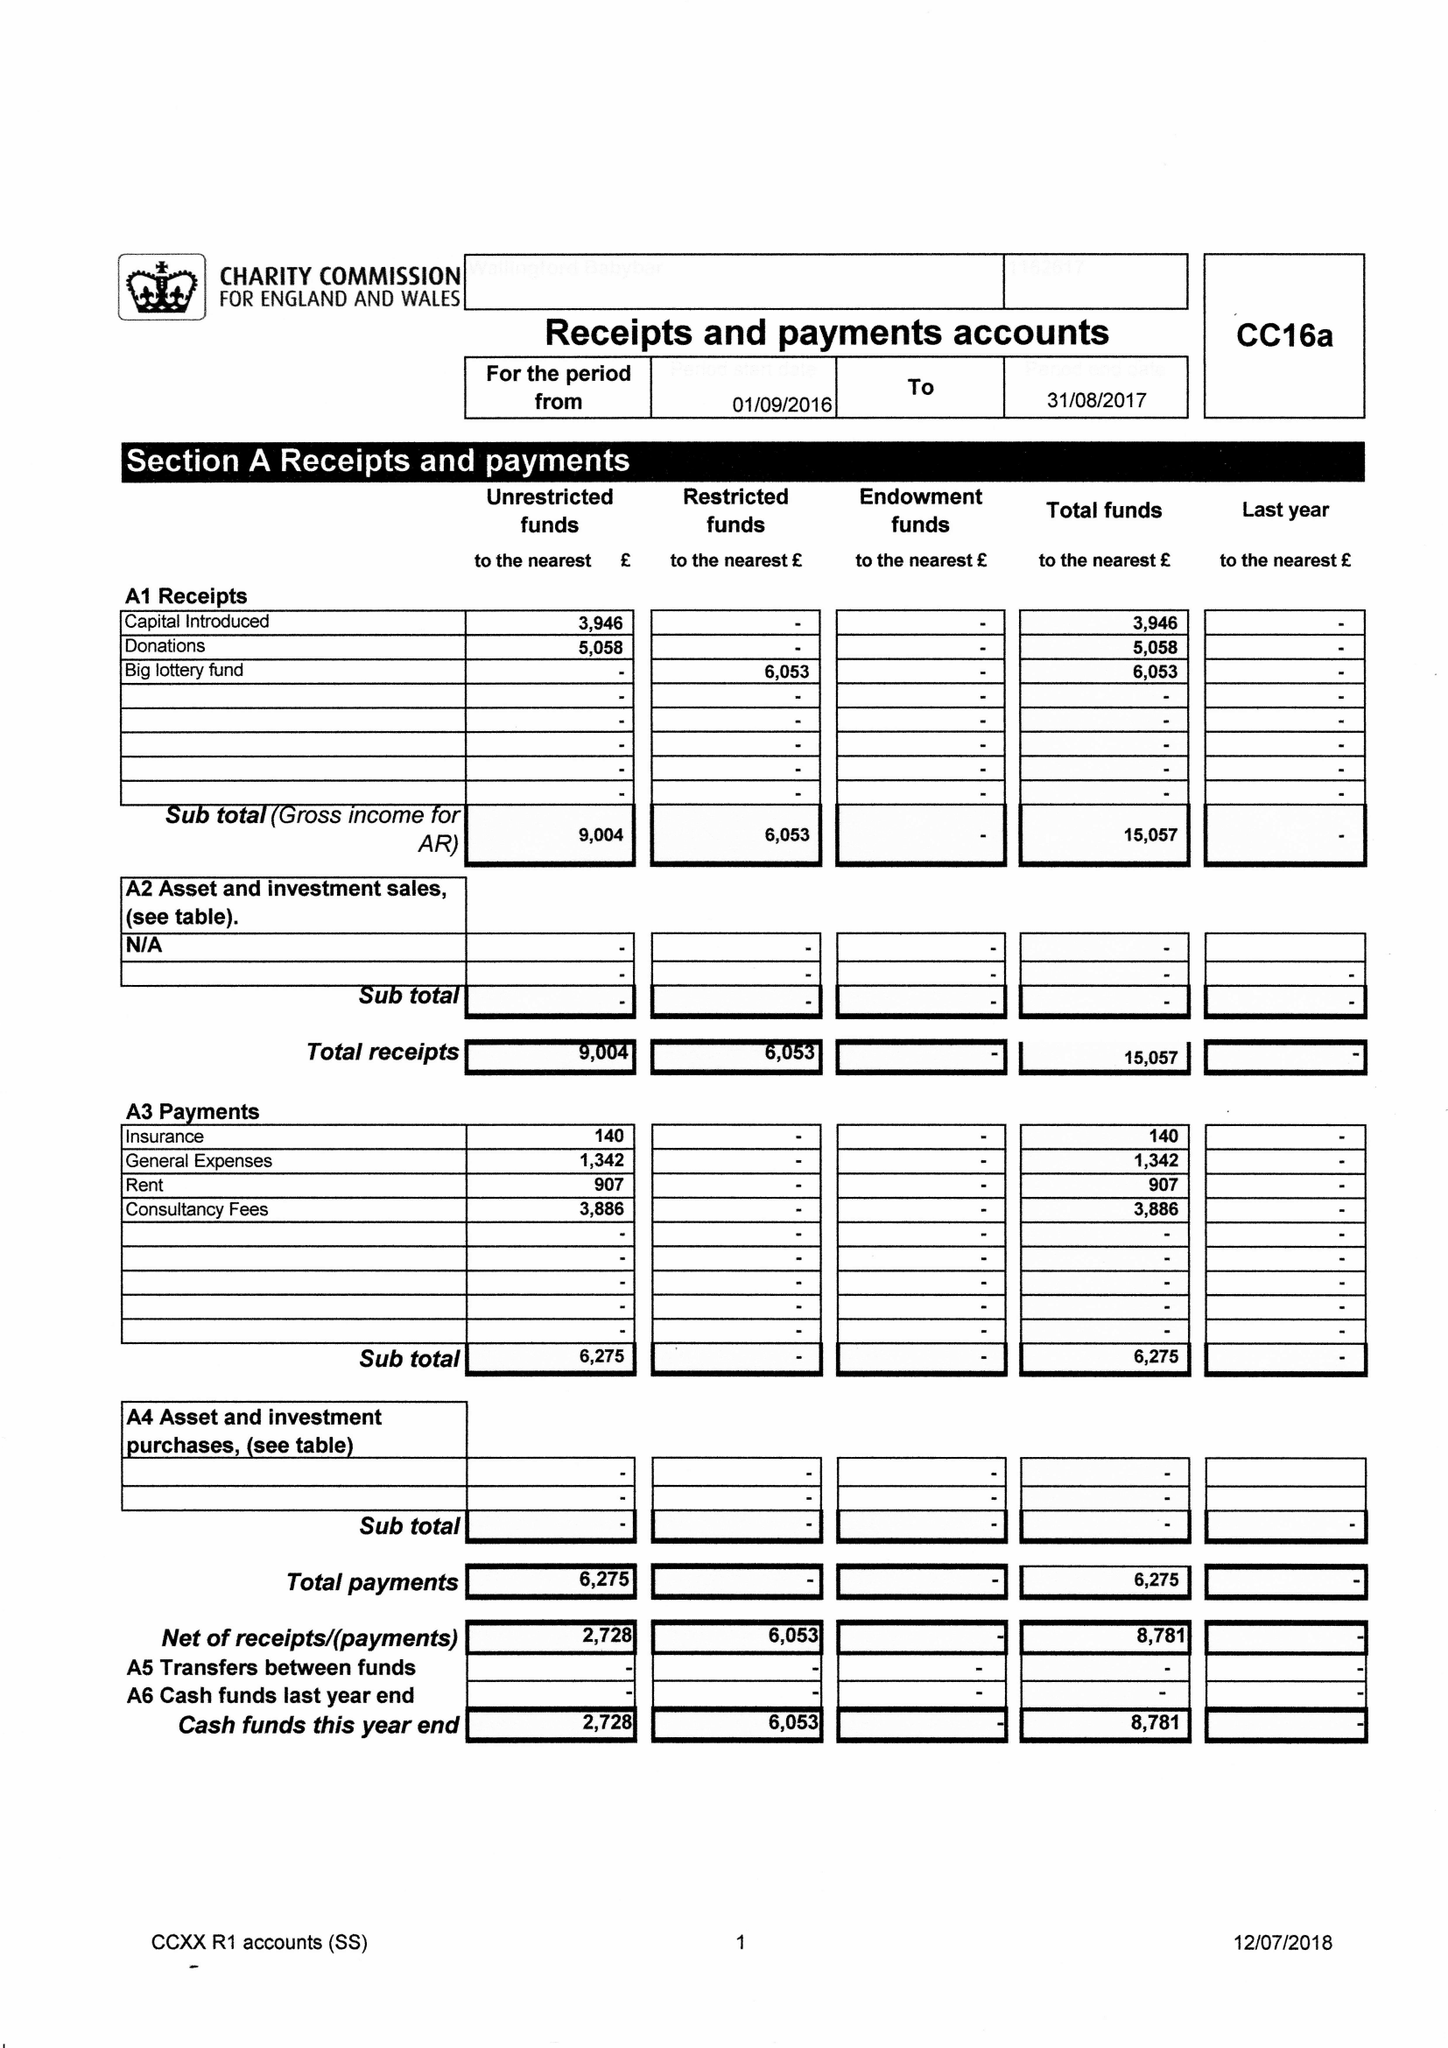What is the value for the address__post_town?
Answer the question using a single word or phrase. WALLINGFORD 